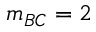<formula> <loc_0><loc_0><loc_500><loc_500>m _ { B C } = 2</formula> 